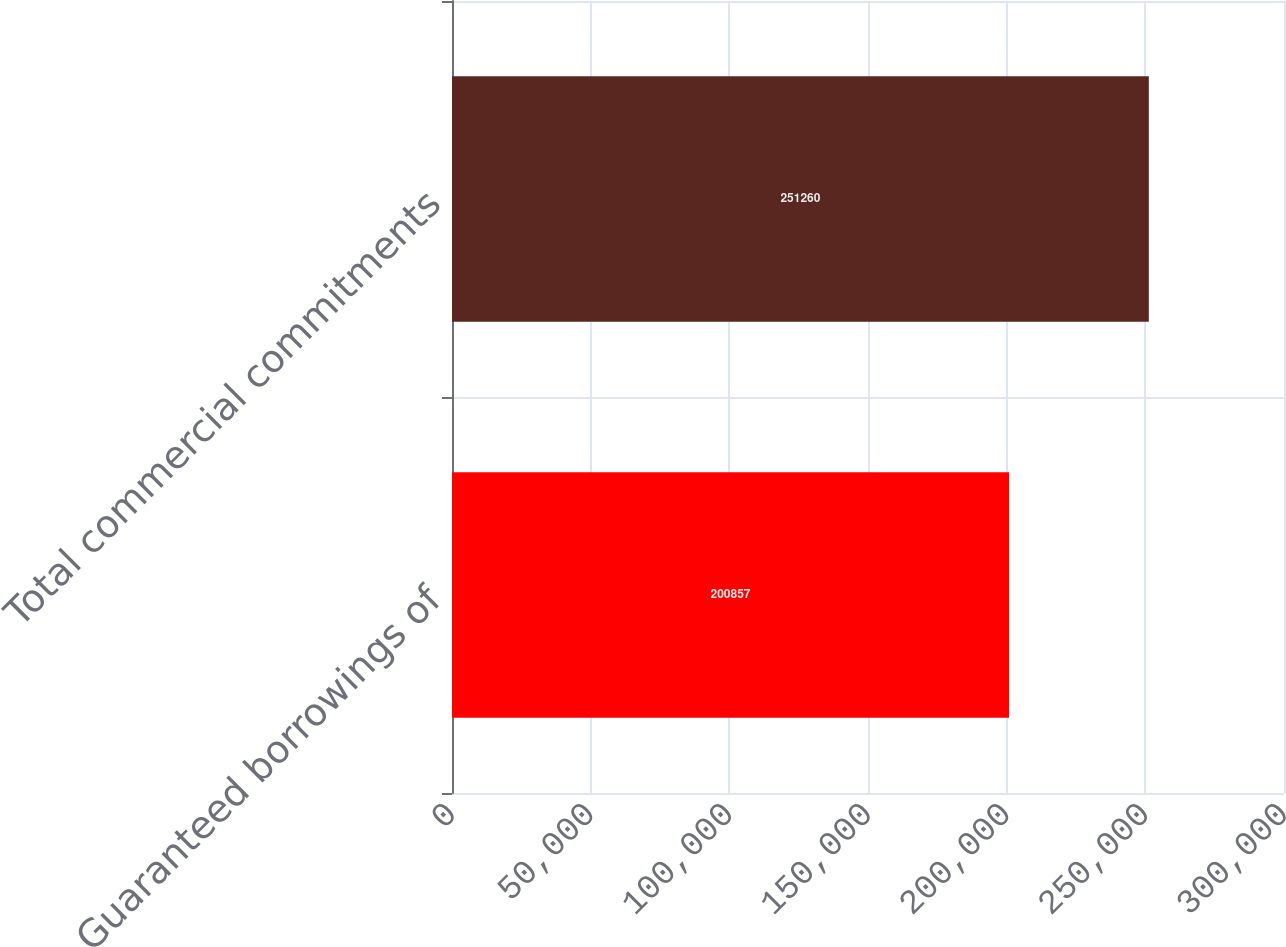Convert chart to OTSL. <chart><loc_0><loc_0><loc_500><loc_500><bar_chart><fcel>Guaranteed borrowings of<fcel>Total commercial commitments<nl><fcel>200857<fcel>251260<nl></chart> 